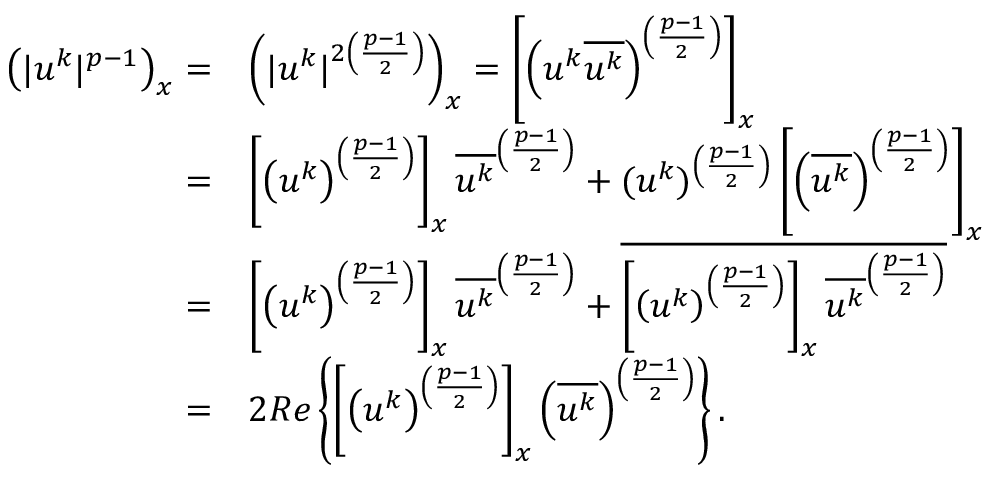Convert formula to latex. <formula><loc_0><loc_0><loc_500><loc_500>\begin{array} { r l } { \left ( | u ^ { k } | ^ { p - 1 } \right ) _ { x } = } & { \left ( | u ^ { k } | ^ { 2 \left ( \frac { p - 1 } { 2 } \right ) } \right ) _ { x } = \left [ \left ( u ^ { k } \overline { { u ^ { k } } } \right ) ^ { \left ( \frac { p - 1 } { 2 } \right ) } \right ] _ { x } } \\ { = } & { \left [ \left ( u ^ { k } \right ) ^ { \left ( \frac { p - 1 } { 2 } \right ) } \right ] _ { x } \overline { { u ^ { k } } } ^ { \left ( \frac { p - 1 } { 2 } \right ) } + ( u ^ { k } ) ^ { \left ( \frac { p - 1 } { 2 } \right ) } \left [ \left ( \overline { { u ^ { k } } } \right ) ^ { \left ( \frac { p - 1 } { 2 } \right ) } \right ] _ { x } } \\ { = } & { \left [ \left ( u ^ { k } \right ) ^ { \left ( \frac { p - 1 } { 2 } \right ) } \right ] _ { x } \overline { { u ^ { k } } } ^ { \left ( \frac { p - 1 } { 2 } \right ) } + \overline { { \left [ \left ( u ^ { k } \right ) ^ { \left ( \frac { p - 1 } { 2 } \right ) } \right ] _ { x } \overline { { u ^ { k } } } ^ { \left ( \frac { p - 1 } { 2 } \right ) } } } } \\ { = } & { 2 R e \left \{ \left [ \left ( u ^ { k } \right ) ^ { \left ( \frac { p - 1 } { 2 } \right ) } \right ] _ { x } \left ( \overline { { u ^ { k } } } \right ) ^ { \left ( \frac { p - 1 } { 2 } \right ) } \right \} . } \end{array}</formula> 